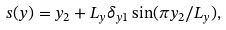<formula> <loc_0><loc_0><loc_500><loc_500>s ( y ) = y _ { 2 } + L _ { y } \delta _ { y 1 } \sin ( \pi y _ { 2 } / L _ { y } ) ,</formula> 